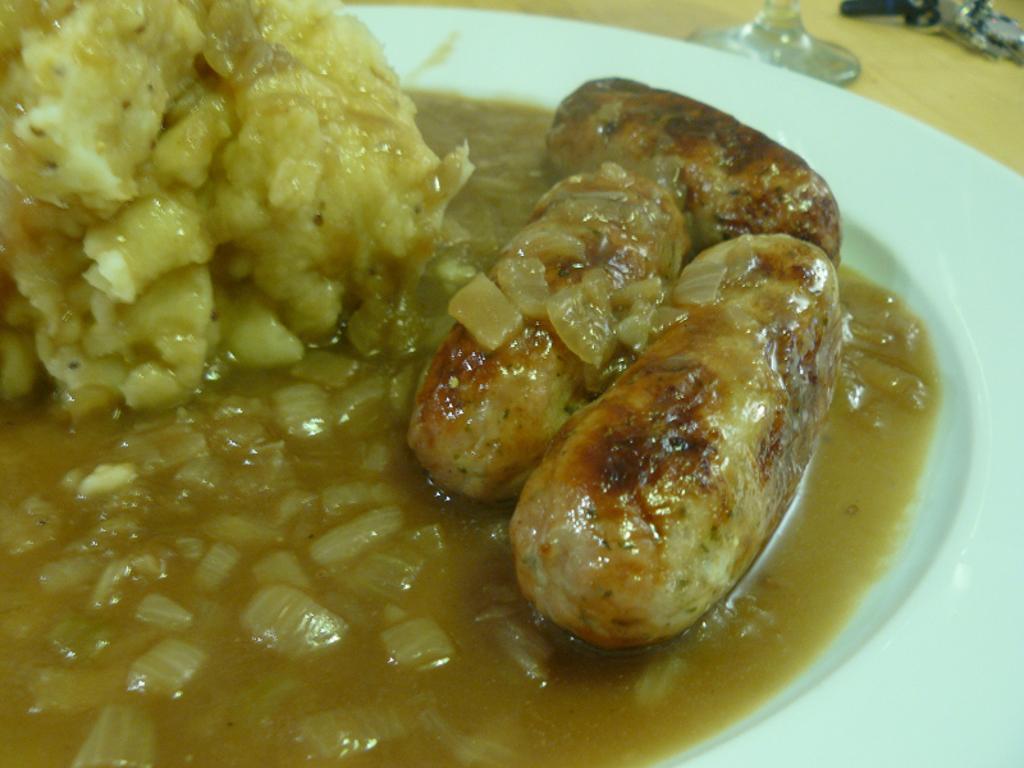Can you describe this image briefly? In this picture we can see food in the plate. 